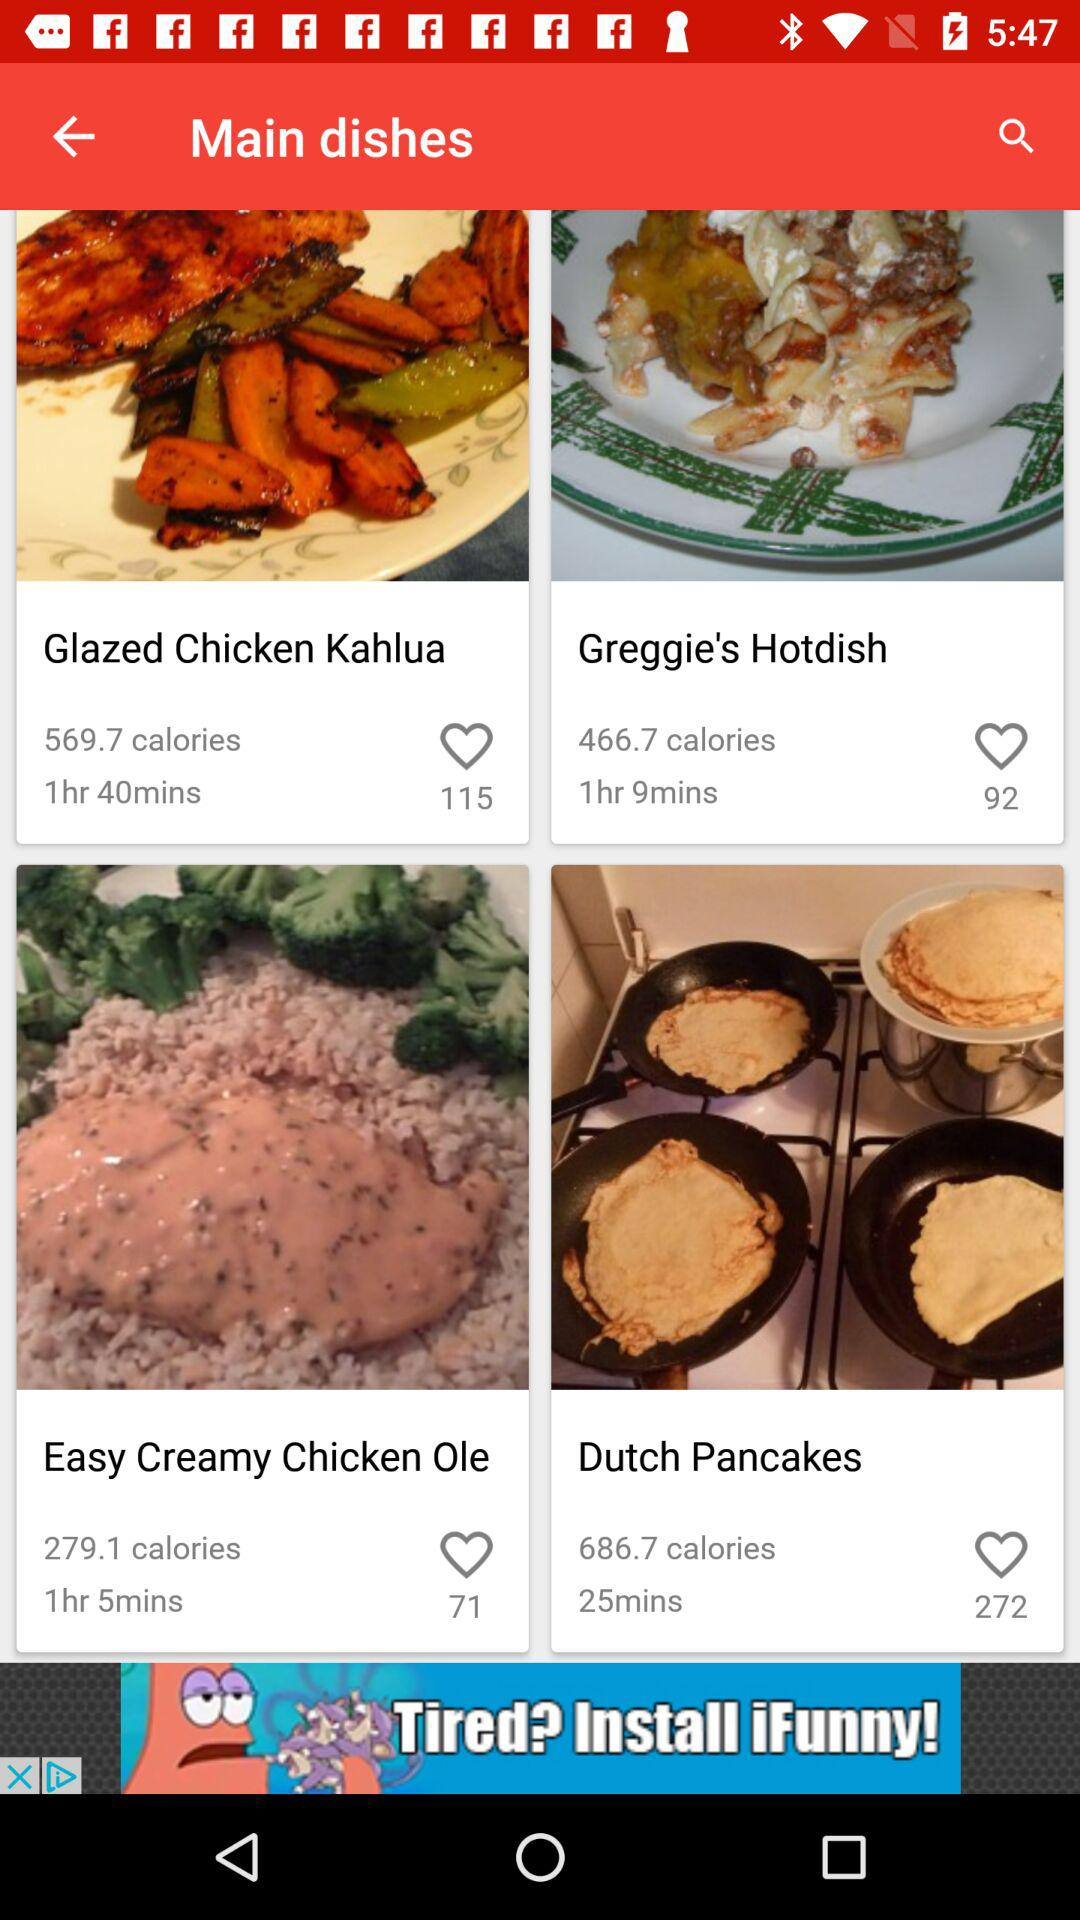What is the cooking time of the "Glazed Chicken Kahlua"? The cooking time of the "Glazed Chicken Kahlua" is 1 hour and 40 minutes. 